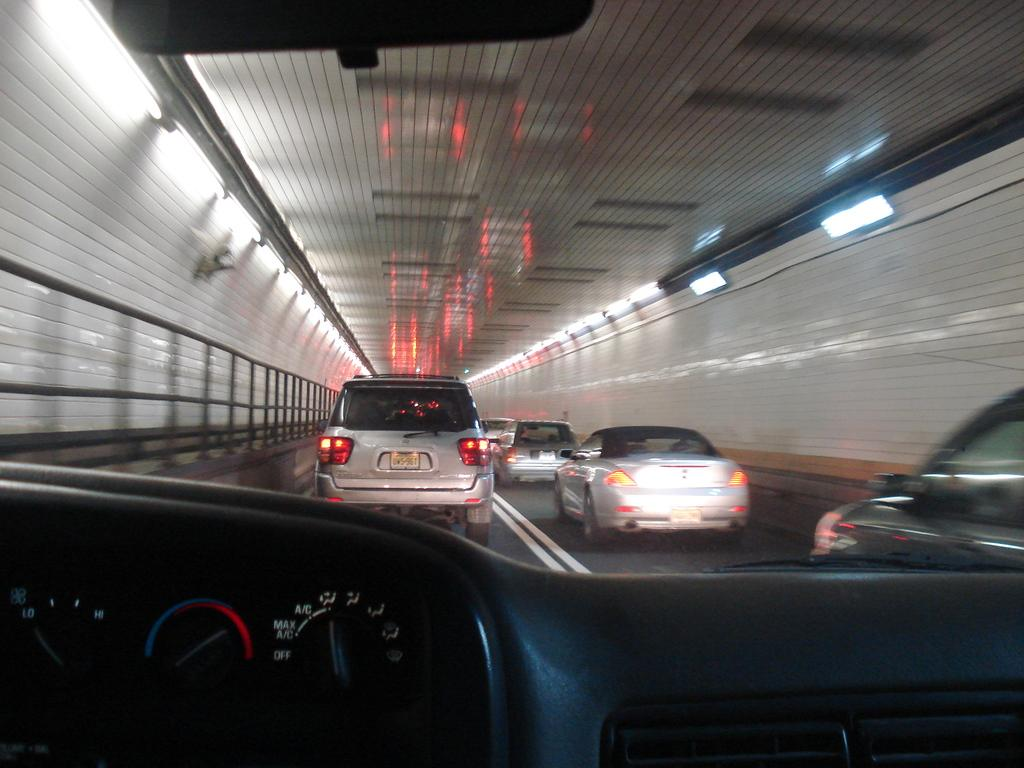What is happening on the road in the image? There are vehicles on the road in the image. What is the status of the road in the image? The road appears to be closed in the image. How many rings are visible on the spoon in the image? There is no spoon or rings present in the image. 